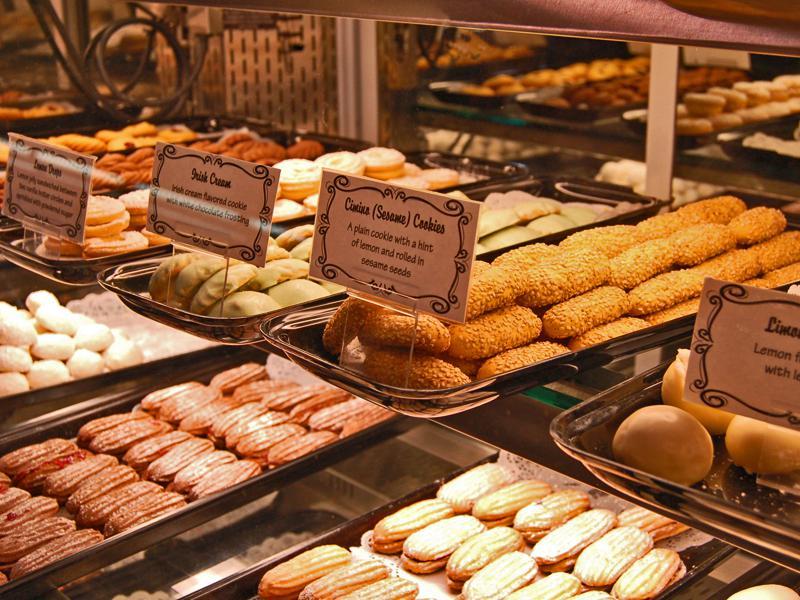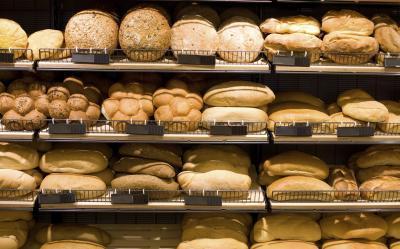The first image is the image on the left, the second image is the image on the right. Examine the images to the left and right. Is the description "The labels are handwritten in one of the images." accurate? Answer yes or no. No. 